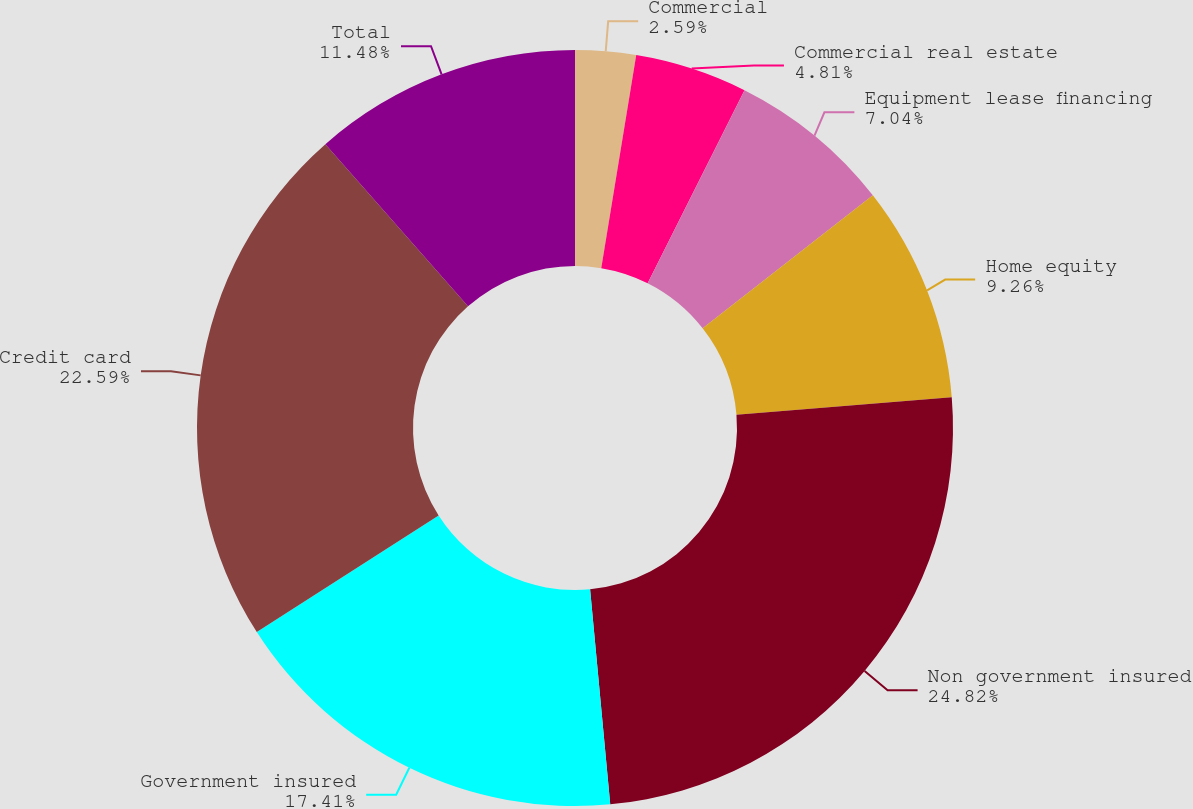<chart> <loc_0><loc_0><loc_500><loc_500><pie_chart><fcel>Commercial<fcel>Commercial real estate<fcel>Equipment lease financing<fcel>Home equity<fcel>Non government insured<fcel>Government insured<fcel>Credit card<fcel>Total<nl><fcel>2.59%<fcel>4.81%<fcel>7.04%<fcel>9.26%<fcel>24.81%<fcel>17.41%<fcel>22.59%<fcel>11.48%<nl></chart> 